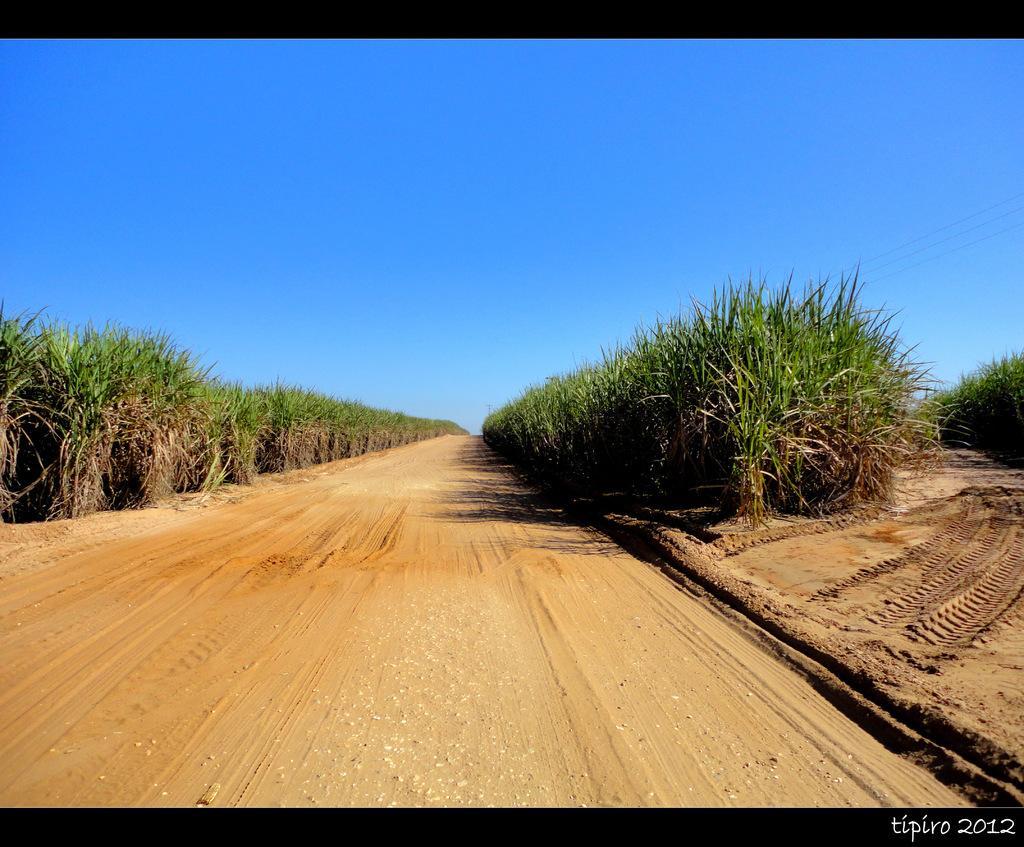How would you summarize this image in a sentence or two? At the bottom of the picture, we see the road or the sand. On either side of the picture, we see the field crops. In the background, we see the sky, which is blue in color. It might be an edited image. 